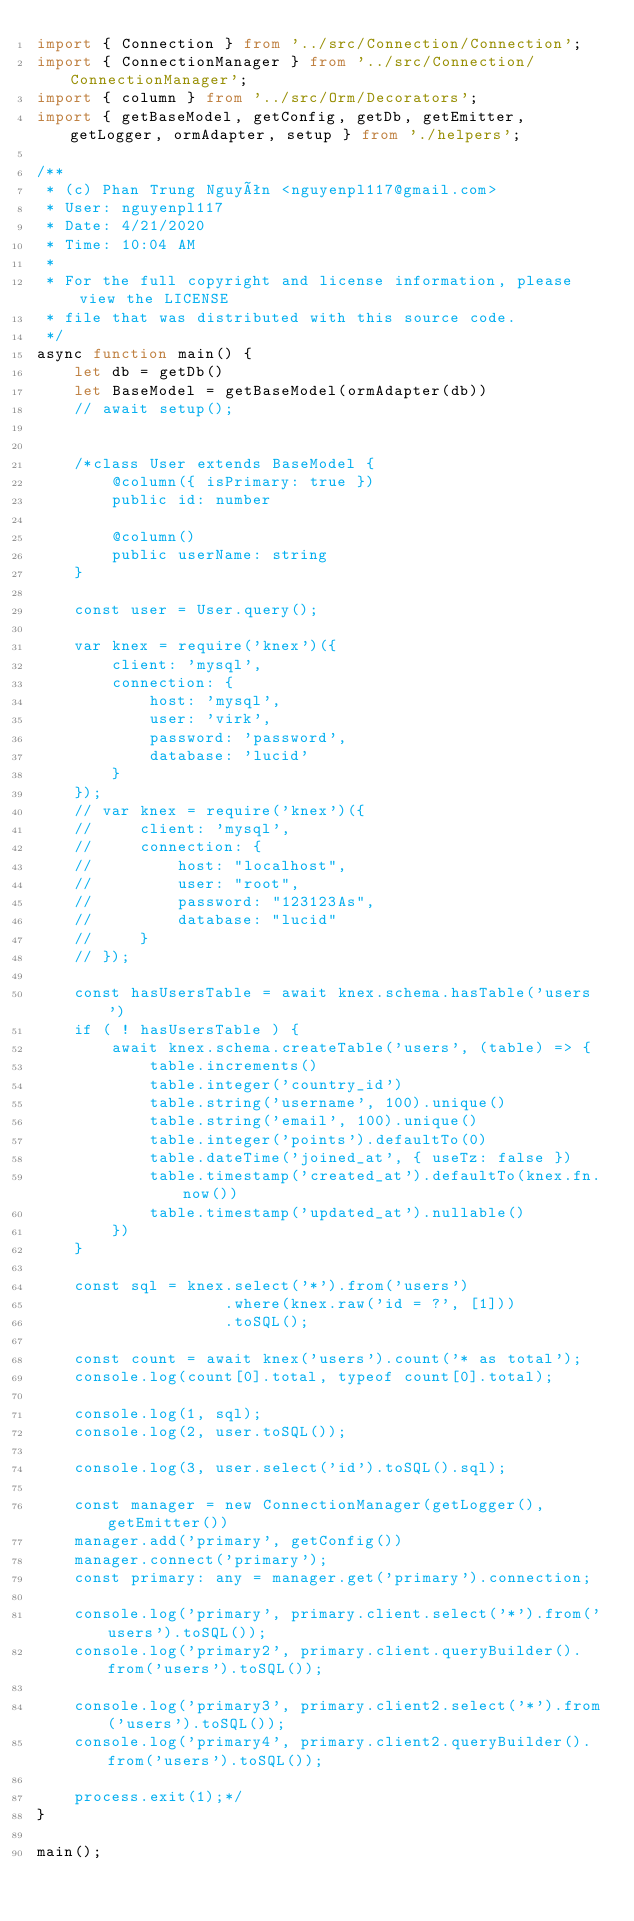Convert code to text. <code><loc_0><loc_0><loc_500><loc_500><_TypeScript_>import { Connection } from '../src/Connection/Connection';
import { ConnectionManager } from '../src/Connection/ConnectionManager';
import { column } from '../src/Orm/Decorators';
import { getBaseModel, getConfig, getDb, getEmitter, getLogger, ormAdapter, setup } from './helpers';

/**
 * (c) Phan Trung Nguyên <nguyenpl117@gmail.com>
 * User: nguyenpl117
 * Date: 4/21/2020
 * Time: 10:04 AM
 *
 * For the full copyright and license information, please view the LICENSE
 * file that was distributed with this source code.
 */
async function main() {
    let db = getDb()
    let BaseModel = getBaseModel(ormAdapter(db))
    // await setup();


    /*class User extends BaseModel {
        @column({ isPrimary: true })
        public id: number

        @column()
        public userName: string
    }

    const user = User.query();

    var knex = require('knex')({
        client: 'mysql',
        connection: {
            host: 'mysql',
            user: 'virk',
            password: 'password',
            database: 'lucid'
        }
    });
    // var knex = require('knex')({
    //     client: 'mysql',
    //     connection: {
    //         host: "localhost",
    //         user: "root",
    //         password: "123123As",
    //         database: "lucid"
    //     }
    // });

    const hasUsersTable = await knex.schema.hasTable('users')
    if ( ! hasUsersTable ) {
        await knex.schema.createTable('users', (table) => {
            table.increments()
            table.integer('country_id')
            table.string('username', 100).unique()
            table.string('email', 100).unique()
            table.integer('points').defaultTo(0)
            table.dateTime('joined_at', { useTz: false })
            table.timestamp('created_at').defaultTo(knex.fn.now())
            table.timestamp('updated_at').nullable()
        })
    }

    const sql = knex.select('*').from('users')
                    .where(knex.raw('id = ?', [1]))
                    .toSQL();

    const count = await knex('users').count('* as total');
    console.log(count[0].total, typeof count[0].total);

    console.log(1, sql);
    console.log(2, user.toSQL());

    console.log(3, user.select('id').toSQL().sql);

    const manager = new ConnectionManager(getLogger(), getEmitter())
    manager.add('primary', getConfig())
    manager.connect('primary');
    const primary: any = manager.get('primary').connection;

    console.log('primary', primary.client.select('*').from('users').toSQL());
    console.log('primary2', primary.client.queryBuilder().from('users').toSQL());

    console.log('primary3', primary.client2.select('*').from('users').toSQL());
    console.log('primary4', primary.client2.queryBuilder().from('users').toSQL());

    process.exit(1);*/
}

main();
</code> 